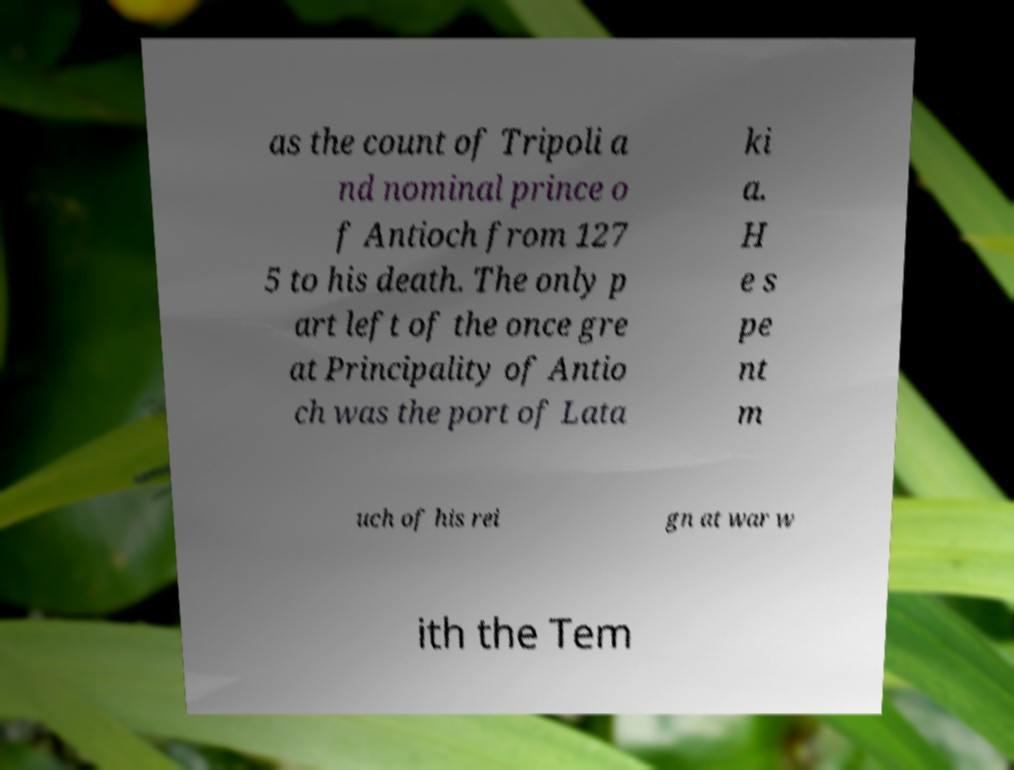Could you assist in decoding the text presented in this image and type it out clearly? as the count of Tripoli a nd nominal prince o f Antioch from 127 5 to his death. The only p art left of the once gre at Principality of Antio ch was the port of Lata ki a. H e s pe nt m uch of his rei gn at war w ith the Tem 